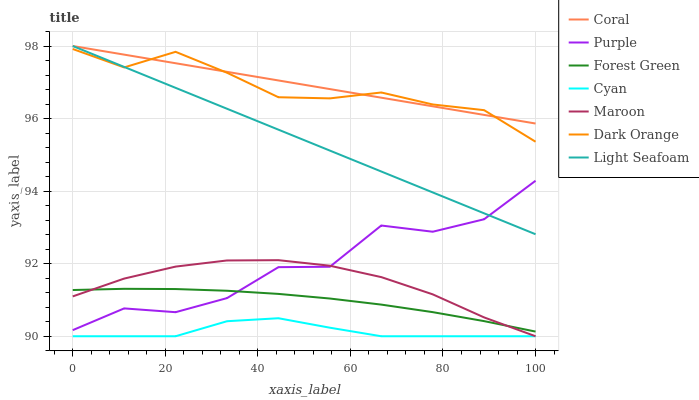Does Purple have the minimum area under the curve?
Answer yes or no. No. Does Purple have the maximum area under the curve?
Answer yes or no. No. Is Purple the smoothest?
Answer yes or no. No. Is Coral the roughest?
Answer yes or no. No. Does Purple have the lowest value?
Answer yes or no. No. Does Purple have the highest value?
Answer yes or no. No. Is Forest Green less than Dark Orange?
Answer yes or no. Yes. Is Light Seafoam greater than Cyan?
Answer yes or no. Yes. Does Forest Green intersect Dark Orange?
Answer yes or no. No. 